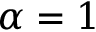<formula> <loc_0><loc_0><loc_500><loc_500>\alpha = 1</formula> 